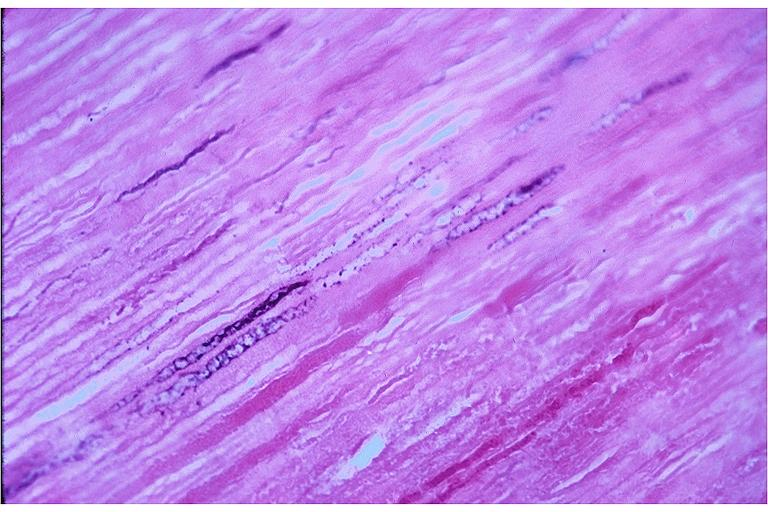where is this?
Answer the question using a single word or phrase. Oral 